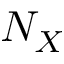Convert formula to latex. <formula><loc_0><loc_0><loc_500><loc_500>N _ { X }</formula> 